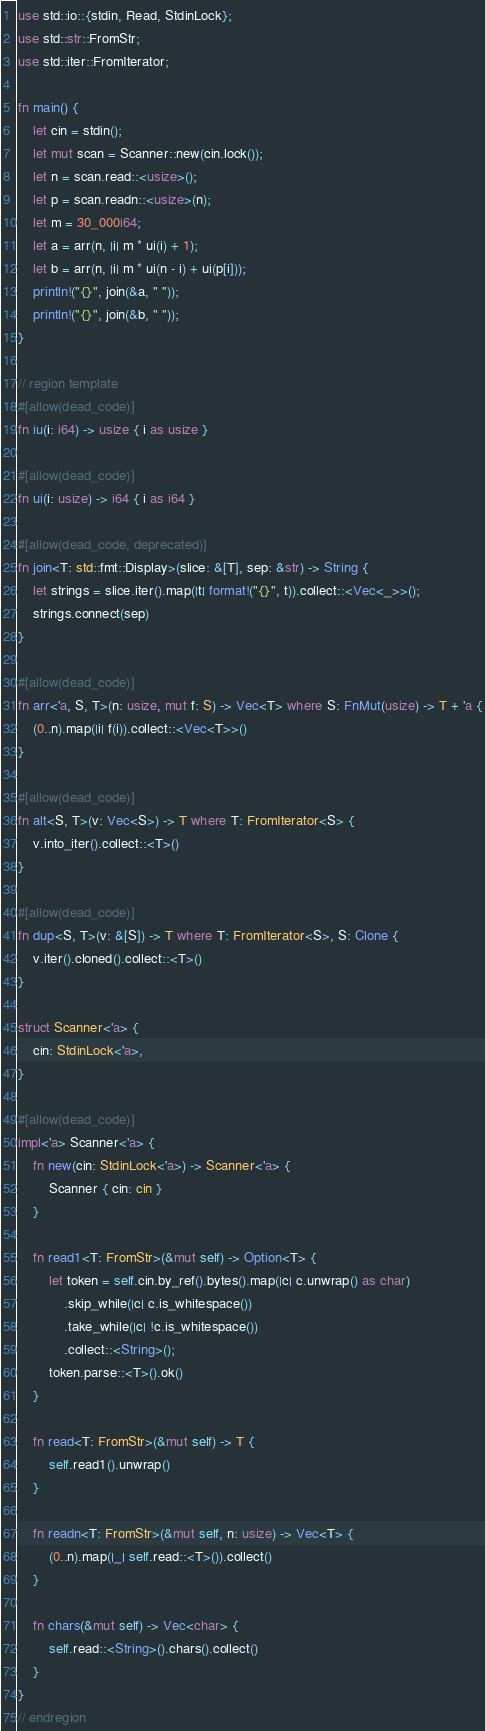Convert code to text. <code><loc_0><loc_0><loc_500><loc_500><_Rust_>use std::io::{stdin, Read, StdinLock};
use std::str::FromStr;
use std::iter::FromIterator;

fn main() {
    let cin = stdin();
    let mut scan = Scanner::new(cin.lock());
    let n = scan.read::<usize>();
    let p = scan.readn::<usize>(n);
    let m = 30_000i64;
    let a = arr(n, |i| m * ui(i) + 1);
    let b = arr(n, |i| m * ui(n - i) + ui(p[i]));
    println!("{}", join(&a, " "));
    println!("{}", join(&b, " "));
}

// region template
#[allow(dead_code)]
fn iu(i: i64) -> usize { i as usize }

#[allow(dead_code)]
fn ui(i: usize) -> i64 { i as i64 }

#[allow(dead_code, deprecated)]
fn join<T: std::fmt::Display>(slice: &[T], sep: &str) -> String {
    let strings = slice.iter().map(|t| format!("{}", t)).collect::<Vec<_>>();
    strings.connect(sep)
}

#[allow(dead_code)]
fn arr<'a, S, T>(n: usize, mut f: S) -> Vec<T> where S: FnMut(usize) -> T + 'a {
    (0..n).map(|i| f(i)).collect::<Vec<T>>()
}

#[allow(dead_code)]
fn alt<S, T>(v: Vec<S>) -> T where T: FromIterator<S> {
    v.into_iter().collect::<T>()
}

#[allow(dead_code)]
fn dup<S, T>(v: &[S]) -> T where T: FromIterator<S>, S: Clone {
    v.iter().cloned().collect::<T>()
}

struct Scanner<'a> {
    cin: StdinLock<'a>,
}

#[allow(dead_code)]
impl<'a> Scanner<'a> {
    fn new(cin: StdinLock<'a>) -> Scanner<'a> {
        Scanner { cin: cin }
    }

    fn read1<T: FromStr>(&mut self) -> Option<T> {
        let token = self.cin.by_ref().bytes().map(|c| c.unwrap() as char)
            .skip_while(|c| c.is_whitespace())
            .take_while(|c| !c.is_whitespace())
            .collect::<String>();
        token.parse::<T>().ok()
    }

    fn read<T: FromStr>(&mut self) -> T {
        self.read1().unwrap()
    }

    fn readn<T: FromStr>(&mut self, n: usize) -> Vec<T> {
        (0..n).map(|_| self.read::<T>()).collect()
    }

    fn chars(&mut self) -> Vec<char> {
        self.read::<String>().chars().collect()
    }
}
// endregion</code> 